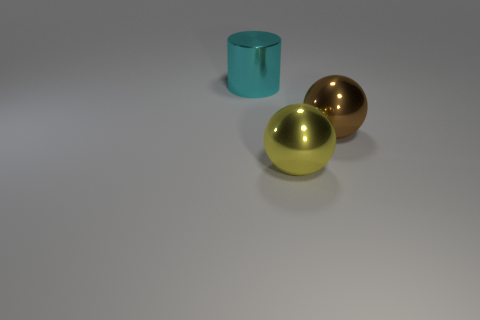What is the size of the brown shiny thing that is the same shape as the yellow metallic object? The size of the brown shiny sphere is comparable to that of the yellow metallic sphere; they both appear to be medium-sized when assessed against the teal cylinder in the image. 